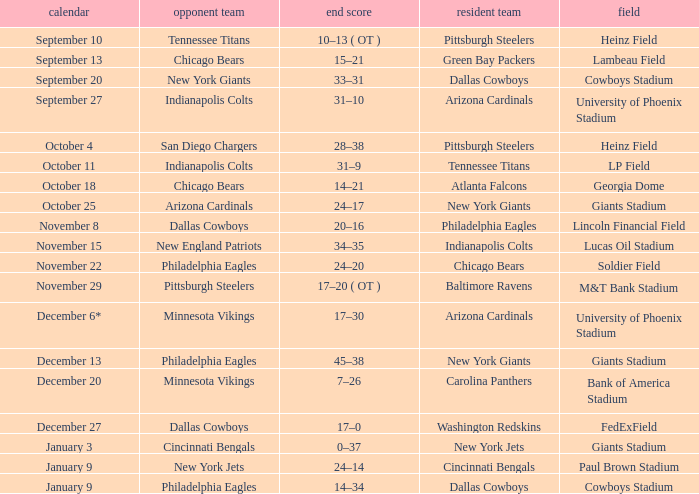Tell me the host team for giants stadium and visiting of cincinnati bengals New York Jets. 